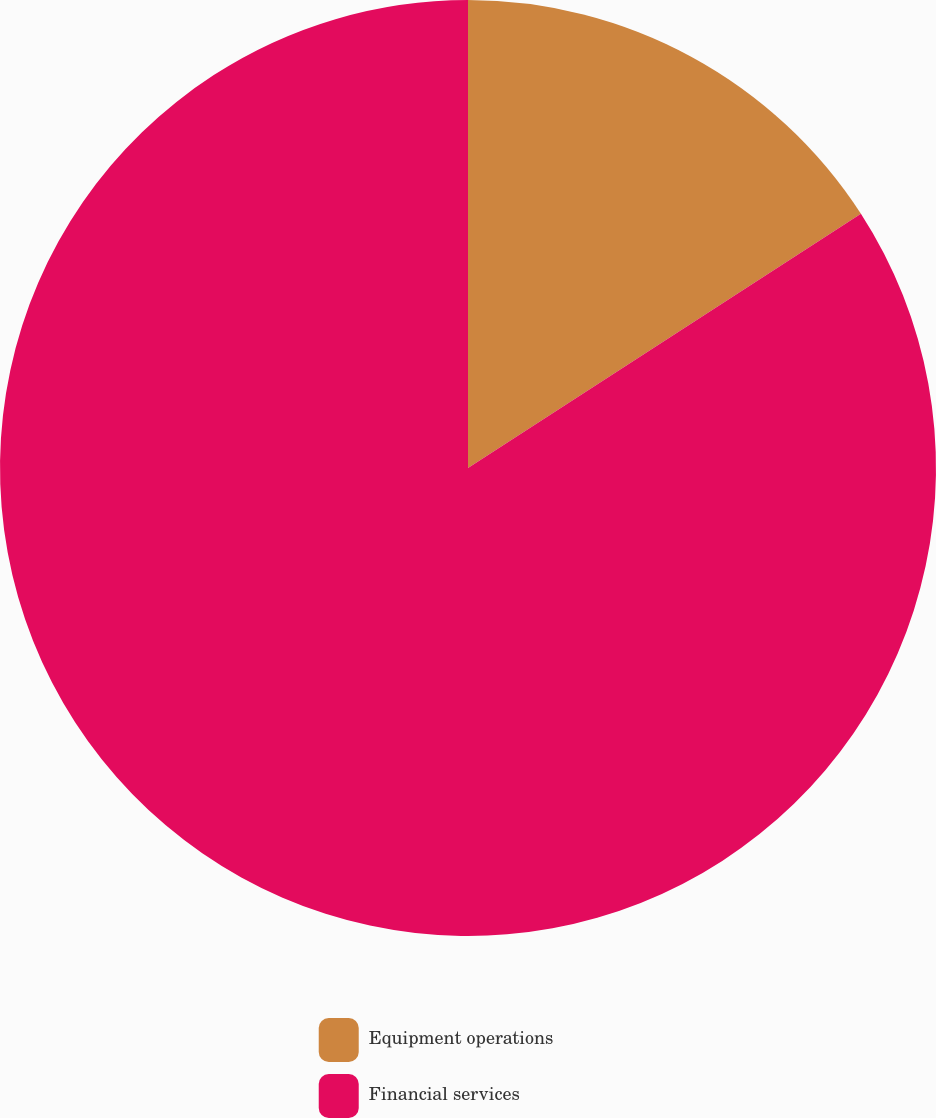<chart> <loc_0><loc_0><loc_500><loc_500><pie_chart><fcel>Equipment operations<fcel>Financial services<nl><fcel>15.86%<fcel>84.14%<nl></chart> 